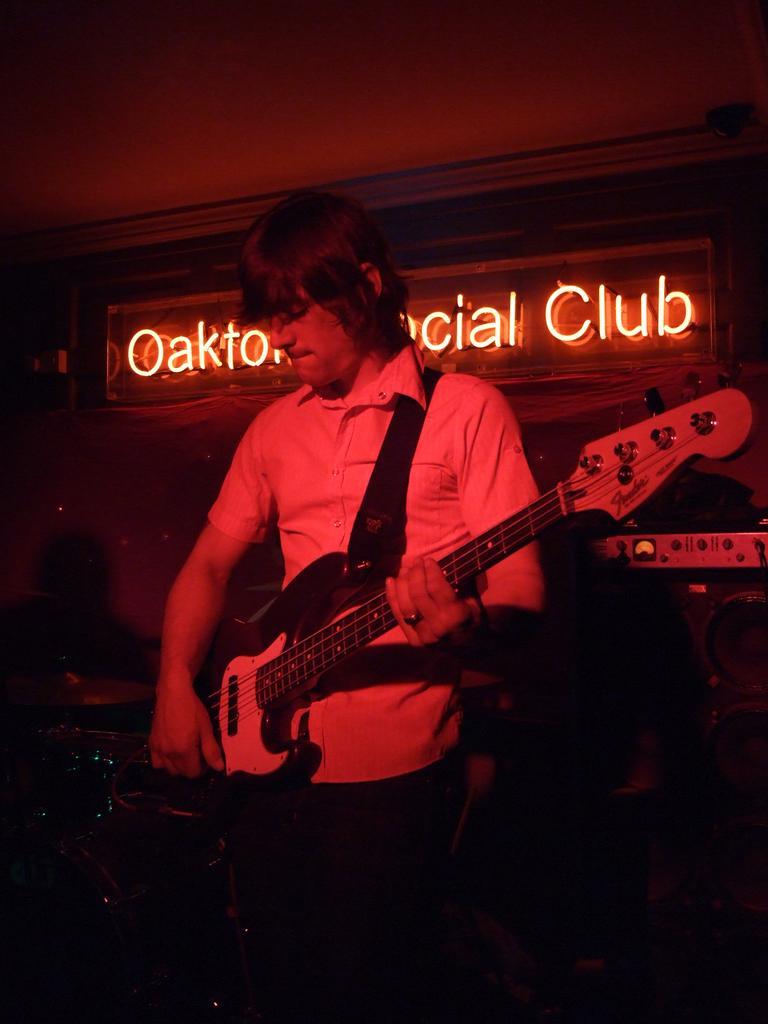Could you give a brief overview of what you see in this image? We can see a man playing a guitar 